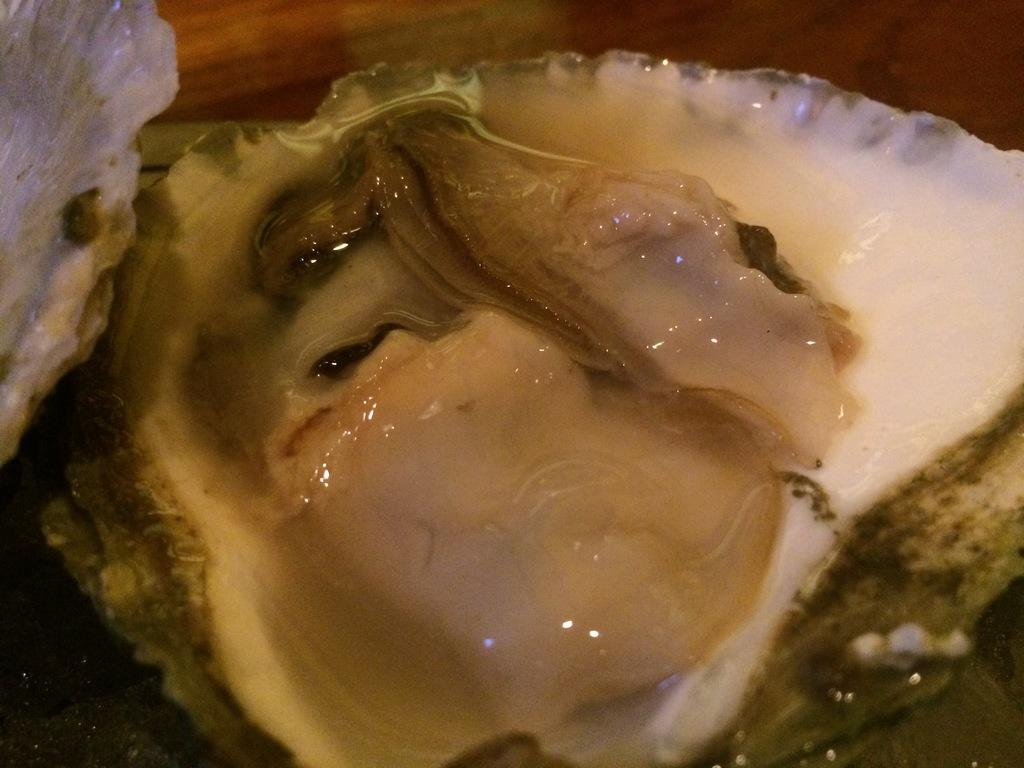What type of objects can be seen in the image? There are seashells and an oyster in the image. Can you describe the seashells in the image? The seashells are likely from the ocean and have a unique shape and texture. What is the oyster's role in the image? The oyster is likely a natural part of the environment where the seashells are found. What grade does the oyster receive for its performance in the image? There is no grading system or performance evaluation in the image, as it is a natural scene with seashells and an oyster. 